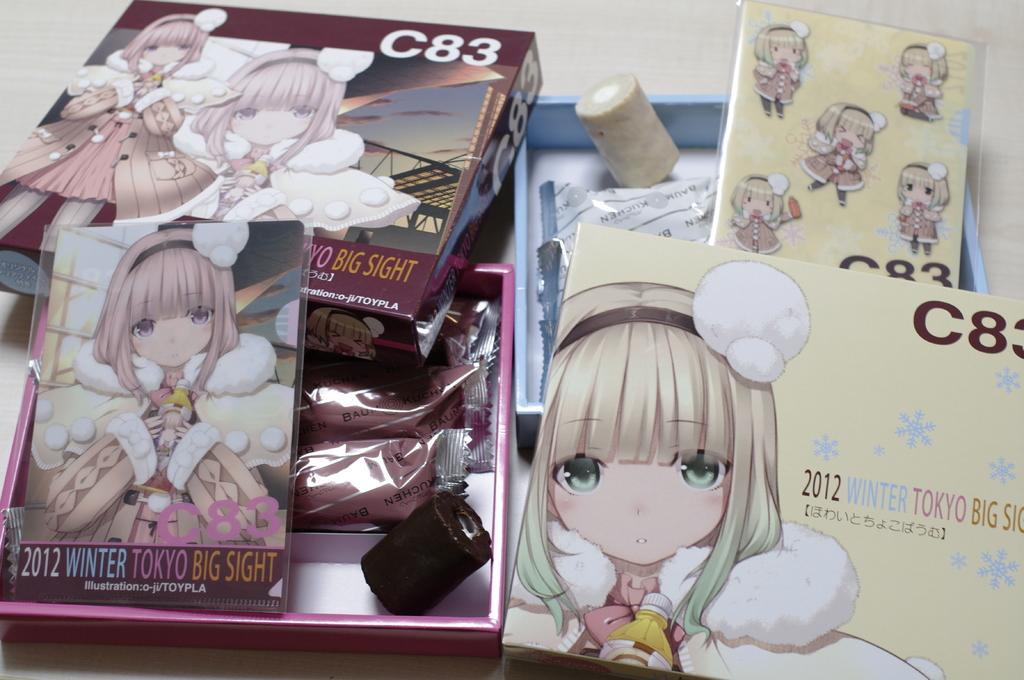Could you give a brief overview of what you see in this image? This picture seems to be clicked inside. On the right there is a blue color box containing the stickers of a doll and some other objects, which is placed on the top of an object. In the foreground we can see the picture of a girl and the text is printed on the top of the box. On the left there is another box containing a book with a picture of a girl and the text on it and there are some items in the box. In the background we can see the lid of a box with the picture of a girl and the picture of the sky and some other objects. 